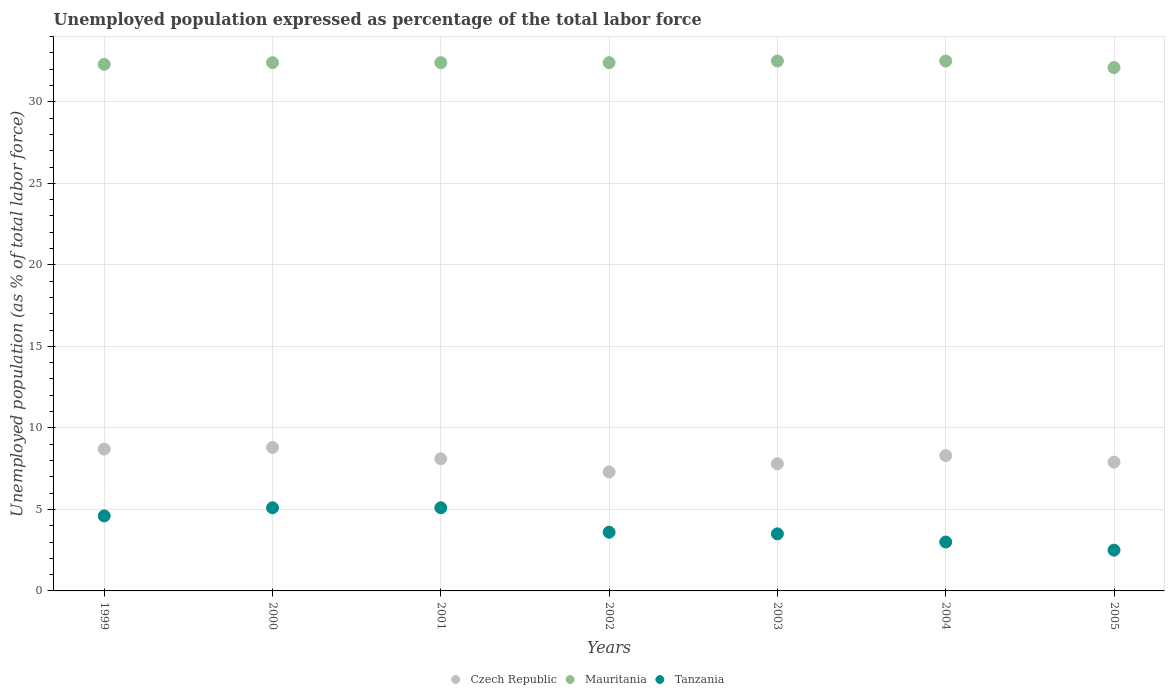How many different coloured dotlines are there?
Offer a very short reply. 3. Is the number of dotlines equal to the number of legend labels?
Offer a very short reply. Yes. What is the unemployment in in Mauritania in 2005?
Ensure brevity in your answer.  32.1. Across all years, what is the maximum unemployment in in Czech Republic?
Your answer should be very brief. 8.8. Across all years, what is the minimum unemployment in in Mauritania?
Provide a short and direct response. 32.1. In which year was the unemployment in in Czech Republic maximum?
Your answer should be very brief. 2000. In which year was the unemployment in in Mauritania minimum?
Offer a very short reply. 2005. What is the total unemployment in in Mauritania in the graph?
Offer a very short reply. 226.6. What is the difference between the unemployment in in Mauritania in 2003 and that in 2005?
Offer a very short reply. 0.4. What is the difference between the unemployment in in Czech Republic in 2000 and the unemployment in in Mauritania in 2005?
Offer a terse response. -23.3. What is the average unemployment in in Czech Republic per year?
Your response must be concise. 8.13. In the year 2000, what is the difference between the unemployment in in Tanzania and unemployment in in Mauritania?
Provide a short and direct response. -27.3. What is the ratio of the unemployment in in Tanzania in 2002 to that in 2003?
Your response must be concise. 1.03. Is the unemployment in in Mauritania in 1999 less than that in 2002?
Ensure brevity in your answer.  Yes. Is the difference between the unemployment in in Tanzania in 1999 and 2004 greater than the difference between the unemployment in in Mauritania in 1999 and 2004?
Your answer should be very brief. Yes. What is the difference between the highest and the second highest unemployment in in Czech Republic?
Your answer should be compact. 0.1. What is the difference between the highest and the lowest unemployment in in Mauritania?
Keep it short and to the point. 0.4. In how many years, is the unemployment in in Tanzania greater than the average unemployment in in Tanzania taken over all years?
Make the answer very short. 3. Is it the case that in every year, the sum of the unemployment in in Mauritania and unemployment in in Tanzania  is greater than the unemployment in in Czech Republic?
Your answer should be very brief. Yes. Does the unemployment in in Czech Republic monotonically increase over the years?
Your answer should be compact. No. Is the unemployment in in Tanzania strictly greater than the unemployment in in Mauritania over the years?
Offer a terse response. No. What is the difference between two consecutive major ticks on the Y-axis?
Offer a terse response. 5. Are the values on the major ticks of Y-axis written in scientific E-notation?
Make the answer very short. No. Does the graph contain any zero values?
Offer a terse response. No. Does the graph contain grids?
Your answer should be compact. Yes. What is the title of the graph?
Ensure brevity in your answer.  Unemployed population expressed as percentage of the total labor force. What is the label or title of the X-axis?
Offer a very short reply. Years. What is the label or title of the Y-axis?
Keep it short and to the point. Unemployed population (as % of total labor force). What is the Unemployed population (as % of total labor force) in Czech Republic in 1999?
Ensure brevity in your answer.  8.7. What is the Unemployed population (as % of total labor force) of Mauritania in 1999?
Provide a succinct answer. 32.3. What is the Unemployed population (as % of total labor force) of Tanzania in 1999?
Offer a terse response. 4.6. What is the Unemployed population (as % of total labor force) in Czech Republic in 2000?
Offer a very short reply. 8.8. What is the Unemployed population (as % of total labor force) of Mauritania in 2000?
Provide a succinct answer. 32.4. What is the Unemployed population (as % of total labor force) of Tanzania in 2000?
Keep it short and to the point. 5.1. What is the Unemployed population (as % of total labor force) of Czech Republic in 2001?
Your answer should be compact. 8.1. What is the Unemployed population (as % of total labor force) of Mauritania in 2001?
Ensure brevity in your answer.  32.4. What is the Unemployed population (as % of total labor force) of Tanzania in 2001?
Your answer should be compact. 5.1. What is the Unemployed population (as % of total labor force) of Czech Republic in 2002?
Your response must be concise. 7.3. What is the Unemployed population (as % of total labor force) of Mauritania in 2002?
Provide a short and direct response. 32.4. What is the Unemployed population (as % of total labor force) in Tanzania in 2002?
Your answer should be compact. 3.6. What is the Unemployed population (as % of total labor force) of Czech Republic in 2003?
Provide a short and direct response. 7.8. What is the Unemployed population (as % of total labor force) of Mauritania in 2003?
Your answer should be compact. 32.5. What is the Unemployed population (as % of total labor force) of Czech Republic in 2004?
Offer a terse response. 8.3. What is the Unemployed population (as % of total labor force) in Mauritania in 2004?
Ensure brevity in your answer.  32.5. What is the Unemployed population (as % of total labor force) of Czech Republic in 2005?
Offer a terse response. 7.9. What is the Unemployed population (as % of total labor force) of Mauritania in 2005?
Keep it short and to the point. 32.1. What is the Unemployed population (as % of total labor force) in Tanzania in 2005?
Make the answer very short. 2.5. Across all years, what is the maximum Unemployed population (as % of total labor force) in Czech Republic?
Provide a succinct answer. 8.8. Across all years, what is the maximum Unemployed population (as % of total labor force) of Mauritania?
Give a very brief answer. 32.5. Across all years, what is the maximum Unemployed population (as % of total labor force) in Tanzania?
Your answer should be very brief. 5.1. Across all years, what is the minimum Unemployed population (as % of total labor force) of Czech Republic?
Provide a succinct answer. 7.3. Across all years, what is the minimum Unemployed population (as % of total labor force) of Mauritania?
Offer a terse response. 32.1. What is the total Unemployed population (as % of total labor force) of Czech Republic in the graph?
Your response must be concise. 56.9. What is the total Unemployed population (as % of total labor force) of Mauritania in the graph?
Offer a very short reply. 226.6. What is the total Unemployed population (as % of total labor force) of Tanzania in the graph?
Ensure brevity in your answer.  27.4. What is the difference between the Unemployed population (as % of total labor force) in Czech Republic in 1999 and that in 2000?
Offer a very short reply. -0.1. What is the difference between the Unemployed population (as % of total labor force) in Mauritania in 1999 and that in 2000?
Your response must be concise. -0.1. What is the difference between the Unemployed population (as % of total labor force) of Czech Republic in 1999 and that in 2002?
Offer a terse response. 1.4. What is the difference between the Unemployed population (as % of total labor force) in Mauritania in 1999 and that in 2002?
Your response must be concise. -0.1. What is the difference between the Unemployed population (as % of total labor force) in Tanzania in 1999 and that in 2002?
Your answer should be very brief. 1. What is the difference between the Unemployed population (as % of total labor force) in Czech Republic in 1999 and that in 2003?
Provide a short and direct response. 0.9. What is the difference between the Unemployed population (as % of total labor force) in Mauritania in 1999 and that in 2003?
Provide a succinct answer. -0.2. What is the difference between the Unemployed population (as % of total labor force) of Tanzania in 1999 and that in 2003?
Keep it short and to the point. 1.1. What is the difference between the Unemployed population (as % of total labor force) in Czech Republic in 1999 and that in 2004?
Provide a short and direct response. 0.4. What is the difference between the Unemployed population (as % of total labor force) in Mauritania in 1999 and that in 2004?
Offer a very short reply. -0.2. What is the difference between the Unemployed population (as % of total labor force) in Tanzania in 1999 and that in 2004?
Make the answer very short. 1.6. What is the difference between the Unemployed population (as % of total labor force) in Mauritania in 1999 and that in 2005?
Give a very brief answer. 0.2. What is the difference between the Unemployed population (as % of total labor force) in Tanzania in 1999 and that in 2005?
Make the answer very short. 2.1. What is the difference between the Unemployed population (as % of total labor force) of Mauritania in 2000 and that in 2001?
Make the answer very short. 0. What is the difference between the Unemployed population (as % of total labor force) of Tanzania in 2000 and that in 2001?
Your answer should be very brief. 0. What is the difference between the Unemployed population (as % of total labor force) in Mauritania in 2000 and that in 2002?
Your answer should be compact. 0. What is the difference between the Unemployed population (as % of total labor force) of Tanzania in 2000 and that in 2002?
Make the answer very short. 1.5. What is the difference between the Unemployed population (as % of total labor force) in Czech Republic in 2000 and that in 2003?
Your answer should be very brief. 1. What is the difference between the Unemployed population (as % of total labor force) of Tanzania in 2000 and that in 2003?
Provide a succinct answer. 1.6. What is the difference between the Unemployed population (as % of total labor force) in Czech Republic in 2000 and that in 2004?
Offer a very short reply. 0.5. What is the difference between the Unemployed population (as % of total labor force) of Tanzania in 2000 and that in 2004?
Give a very brief answer. 2.1. What is the difference between the Unemployed population (as % of total labor force) of Tanzania in 2000 and that in 2005?
Your answer should be very brief. 2.6. What is the difference between the Unemployed population (as % of total labor force) of Czech Republic in 2001 and that in 2002?
Ensure brevity in your answer.  0.8. What is the difference between the Unemployed population (as % of total labor force) in Tanzania in 2001 and that in 2002?
Ensure brevity in your answer.  1.5. What is the difference between the Unemployed population (as % of total labor force) of Mauritania in 2001 and that in 2003?
Your response must be concise. -0.1. What is the difference between the Unemployed population (as % of total labor force) in Mauritania in 2001 and that in 2004?
Provide a succinct answer. -0.1. What is the difference between the Unemployed population (as % of total labor force) of Mauritania in 2001 and that in 2005?
Make the answer very short. 0.3. What is the difference between the Unemployed population (as % of total labor force) of Czech Republic in 2002 and that in 2005?
Offer a very short reply. -0.6. What is the difference between the Unemployed population (as % of total labor force) of Tanzania in 2002 and that in 2005?
Provide a succinct answer. 1.1. What is the difference between the Unemployed population (as % of total labor force) in Czech Republic in 2003 and that in 2004?
Offer a terse response. -0.5. What is the difference between the Unemployed population (as % of total labor force) of Mauritania in 2003 and that in 2004?
Your answer should be compact. 0. What is the difference between the Unemployed population (as % of total labor force) of Czech Republic in 2003 and that in 2005?
Make the answer very short. -0.1. What is the difference between the Unemployed population (as % of total labor force) in Tanzania in 2004 and that in 2005?
Offer a very short reply. 0.5. What is the difference between the Unemployed population (as % of total labor force) in Czech Republic in 1999 and the Unemployed population (as % of total labor force) in Mauritania in 2000?
Provide a short and direct response. -23.7. What is the difference between the Unemployed population (as % of total labor force) in Czech Republic in 1999 and the Unemployed population (as % of total labor force) in Tanzania in 2000?
Your answer should be compact. 3.6. What is the difference between the Unemployed population (as % of total labor force) in Mauritania in 1999 and the Unemployed population (as % of total labor force) in Tanzania in 2000?
Your response must be concise. 27.2. What is the difference between the Unemployed population (as % of total labor force) of Czech Republic in 1999 and the Unemployed population (as % of total labor force) of Mauritania in 2001?
Provide a short and direct response. -23.7. What is the difference between the Unemployed population (as % of total labor force) in Mauritania in 1999 and the Unemployed population (as % of total labor force) in Tanzania in 2001?
Offer a very short reply. 27.2. What is the difference between the Unemployed population (as % of total labor force) in Czech Republic in 1999 and the Unemployed population (as % of total labor force) in Mauritania in 2002?
Your response must be concise. -23.7. What is the difference between the Unemployed population (as % of total labor force) in Czech Republic in 1999 and the Unemployed population (as % of total labor force) in Tanzania in 2002?
Ensure brevity in your answer.  5.1. What is the difference between the Unemployed population (as % of total labor force) in Mauritania in 1999 and the Unemployed population (as % of total labor force) in Tanzania in 2002?
Make the answer very short. 28.7. What is the difference between the Unemployed population (as % of total labor force) in Czech Republic in 1999 and the Unemployed population (as % of total labor force) in Mauritania in 2003?
Keep it short and to the point. -23.8. What is the difference between the Unemployed population (as % of total labor force) in Mauritania in 1999 and the Unemployed population (as % of total labor force) in Tanzania in 2003?
Make the answer very short. 28.8. What is the difference between the Unemployed population (as % of total labor force) of Czech Republic in 1999 and the Unemployed population (as % of total labor force) of Mauritania in 2004?
Ensure brevity in your answer.  -23.8. What is the difference between the Unemployed population (as % of total labor force) of Czech Republic in 1999 and the Unemployed population (as % of total labor force) of Tanzania in 2004?
Provide a short and direct response. 5.7. What is the difference between the Unemployed population (as % of total labor force) in Mauritania in 1999 and the Unemployed population (as % of total labor force) in Tanzania in 2004?
Your response must be concise. 29.3. What is the difference between the Unemployed population (as % of total labor force) of Czech Republic in 1999 and the Unemployed population (as % of total labor force) of Mauritania in 2005?
Ensure brevity in your answer.  -23.4. What is the difference between the Unemployed population (as % of total labor force) of Czech Republic in 1999 and the Unemployed population (as % of total labor force) of Tanzania in 2005?
Ensure brevity in your answer.  6.2. What is the difference between the Unemployed population (as % of total labor force) in Mauritania in 1999 and the Unemployed population (as % of total labor force) in Tanzania in 2005?
Provide a succinct answer. 29.8. What is the difference between the Unemployed population (as % of total labor force) in Czech Republic in 2000 and the Unemployed population (as % of total labor force) in Mauritania in 2001?
Provide a succinct answer. -23.6. What is the difference between the Unemployed population (as % of total labor force) in Mauritania in 2000 and the Unemployed population (as % of total labor force) in Tanzania in 2001?
Your response must be concise. 27.3. What is the difference between the Unemployed population (as % of total labor force) in Czech Republic in 2000 and the Unemployed population (as % of total labor force) in Mauritania in 2002?
Provide a short and direct response. -23.6. What is the difference between the Unemployed population (as % of total labor force) in Mauritania in 2000 and the Unemployed population (as % of total labor force) in Tanzania in 2002?
Your answer should be compact. 28.8. What is the difference between the Unemployed population (as % of total labor force) in Czech Republic in 2000 and the Unemployed population (as % of total labor force) in Mauritania in 2003?
Your answer should be compact. -23.7. What is the difference between the Unemployed population (as % of total labor force) of Mauritania in 2000 and the Unemployed population (as % of total labor force) of Tanzania in 2003?
Give a very brief answer. 28.9. What is the difference between the Unemployed population (as % of total labor force) in Czech Republic in 2000 and the Unemployed population (as % of total labor force) in Mauritania in 2004?
Your response must be concise. -23.7. What is the difference between the Unemployed population (as % of total labor force) in Czech Republic in 2000 and the Unemployed population (as % of total labor force) in Tanzania in 2004?
Your answer should be very brief. 5.8. What is the difference between the Unemployed population (as % of total labor force) of Mauritania in 2000 and the Unemployed population (as % of total labor force) of Tanzania in 2004?
Your answer should be very brief. 29.4. What is the difference between the Unemployed population (as % of total labor force) in Czech Republic in 2000 and the Unemployed population (as % of total labor force) in Mauritania in 2005?
Make the answer very short. -23.3. What is the difference between the Unemployed population (as % of total labor force) in Mauritania in 2000 and the Unemployed population (as % of total labor force) in Tanzania in 2005?
Make the answer very short. 29.9. What is the difference between the Unemployed population (as % of total labor force) of Czech Republic in 2001 and the Unemployed population (as % of total labor force) of Mauritania in 2002?
Provide a succinct answer. -24.3. What is the difference between the Unemployed population (as % of total labor force) of Mauritania in 2001 and the Unemployed population (as % of total labor force) of Tanzania in 2002?
Your answer should be compact. 28.8. What is the difference between the Unemployed population (as % of total labor force) in Czech Republic in 2001 and the Unemployed population (as % of total labor force) in Mauritania in 2003?
Your answer should be very brief. -24.4. What is the difference between the Unemployed population (as % of total labor force) in Czech Republic in 2001 and the Unemployed population (as % of total labor force) in Tanzania in 2003?
Keep it short and to the point. 4.6. What is the difference between the Unemployed population (as % of total labor force) of Mauritania in 2001 and the Unemployed population (as % of total labor force) of Tanzania in 2003?
Give a very brief answer. 28.9. What is the difference between the Unemployed population (as % of total labor force) in Czech Republic in 2001 and the Unemployed population (as % of total labor force) in Mauritania in 2004?
Keep it short and to the point. -24.4. What is the difference between the Unemployed population (as % of total labor force) of Mauritania in 2001 and the Unemployed population (as % of total labor force) of Tanzania in 2004?
Provide a succinct answer. 29.4. What is the difference between the Unemployed population (as % of total labor force) in Mauritania in 2001 and the Unemployed population (as % of total labor force) in Tanzania in 2005?
Your answer should be compact. 29.9. What is the difference between the Unemployed population (as % of total labor force) in Czech Republic in 2002 and the Unemployed population (as % of total labor force) in Mauritania in 2003?
Offer a very short reply. -25.2. What is the difference between the Unemployed population (as % of total labor force) of Mauritania in 2002 and the Unemployed population (as % of total labor force) of Tanzania in 2003?
Your answer should be compact. 28.9. What is the difference between the Unemployed population (as % of total labor force) of Czech Republic in 2002 and the Unemployed population (as % of total labor force) of Mauritania in 2004?
Provide a succinct answer. -25.2. What is the difference between the Unemployed population (as % of total labor force) in Czech Republic in 2002 and the Unemployed population (as % of total labor force) in Tanzania in 2004?
Offer a very short reply. 4.3. What is the difference between the Unemployed population (as % of total labor force) of Mauritania in 2002 and the Unemployed population (as % of total labor force) of Tanzania in 2004?
Keep it short and to the point. 29.4. What is the difference between the Unemployed population (as % of total labor force) in Czech Republic in 2002 and the Unemployed population (as % of total labor force) in Mauritania in 2005?
Make the answer very short. -24.8. What is the difference between the Unemployed population (as % of total labor force) of Mauritania in 2002 and the Unemployed population (as % of total labor force) of Tanzania in 2005?
Provide a succinct answer. 29.9. What is the difference between the Unemployed population (as % of total labor force) in Czech Republic in 2003 and the Unemployed population (as % of total labor force) in Mauritania in 2004?
Keep it short and to the point. -24.7. What is the difference between the Unemployed population (as % of total labor force) of Mauritania in 2003 and the Unemployed population (as % of total labor force) of Tanzania in 2004?
Keep it short and to the point. 29.5. What is the difference between the Unemployed population (as % of total labor force) in Czech Republic in 2003 and the Unemployed population (as % of total labor force) in Mauritania in 2005?
Provide a succinct answer. -24.3. What is the difference between the Unemployed population (as % of total labor force) of Czech Republic in 2004 and the Unemployed population (as % of total labor force) of Mauritania in 2005?
Ensure brevity in your answer.  -23.8. What is the average Unemployed population (as % of total labor force) in Czech Republic per year?
Offer a terse response. 8.13. What is the average Unemployed population (as % of total labor force) of Mauritania per year?
Provide a short and direct response. 32.37. What is the average Unemployed population (as % of total labor force) in Tanzania per year?
Give a very brief answer. 3.91. In the year 1999, what is the difference between the Unemployed population (as % of total labor force) of Czech Republic and Unemployed population (as % of total labor force) of Mauritania?
Your answer should be compact. -23.6. In the year 1999, what is the difference between the Unemployed population (as % of total labor force) of Czech Republic and Unemployed population (as % of total labor force) of Tanzania?
Provide a succinct answer. 4.1. In the year 1999, what is the difference between the Unemployed population (as % of total labor force) of Mauritania and Unemployed population (as % of total labor force) of Tanzania?
Keep it short and to the point. 27.7. In the year 2000, what is the difference between the Unemployed population (as % of total labor force) in Czech Republic and Unemployed population (as % of total labor force) in Mauritania?
Offer a very short reply. -23.6. In the year 2000, what is the difference between the Unemployed population (as % of total labor force) of Mauritania and Unemployed population (as % of total labor force) of Tanzania?
Offer a very short reply. 27.3. In the year 2001, what is the difference between the Unemployed population (as % of total labor force) of Czech Republic and Unemployed population (as % of total labor force) of Mauritania?
Provide a succinct answer. -24.3. In the year 2001, what is the difference between the Unemployed population (as % of total labor force) in Czech Republic and Unemployed population (as % of total labor force) in Tanzania?
Provide a short and direct response. 3. In the year 2001, what is the difference between the Unemployed population (as % of total labor force) of Mauritania and Unemployed population (as % of total labor force) of Tanzania?
Provide a succinct answer. 27.3. In the year 2002, what is the difference between the Unemployed population (as % of total labor force) in Czech Republic and Unemployed population (as % of total labor force) in Mauritania?
Your response must be concise. -25.1. In the year 2002, what is the difference between the Unemployed population (as % of total labor force) in Mauritania and Unemployed population (as % of total labor force) in Tanzania?
Keep it short and to the point. 28.8. In the year 2003, what is the difference between the Unemployed population (as % of total labor force) in Czech Republic and Unemployed population (as % of total labor force) in Mauritania?
Keep it short and to the point. -24.7. In the year 2004, what is the difference between the Unemployed population (as % of total labor force) of Czech Republic and Unemployed population (as % of total labor force) of Mauritania?
Give a very brief answer. -24.2. In the year 2004, what is the difference between the Unemployed population (as % of total labor force) in Mauritania and Unemployed population (as % of total labor force) in Tanzania?
Your answer should be compact. 29.5. In the year 2005, what is the difference between the Unemployed population (as % of total labor force) in Czech Republic and Unemployed population (as % of total labor force) in Mauritania?
Provide a short and direct response. -24.2. In the year 2005, what is the difference between the Unemployed population (as % of total labor force) of Czech Republic and Unemployed population (as % of total labor force) of Tanzania?
Make the answer very short. 5.4. In the year 2005, what is the difference between the Unemployed population (as % of total labor force) in Mauritania and Unemployed population (as % of total labor force) in Tanzania?
Provide a short and direct response. 29.6. What is the ratio of the Unemployed population (as % of total labor force) of Czech Republic in 1999 to that in 2000?
Your answer should be compact. 0.99. What is the ratio of the Unemployed population (as % of total labor force) of Mauritania in 1999 to that in 2000?
Your answer should be compact. 1. What is the ratio of the Unemployed population (as % of total labor force) in Tanzania in 1999 to that in 2000?
Your response must be concise. 0.9. What is the ratio of the Unemployed population (as % of total labor force) in Czech Republic in 1999 to that in 2001?
Your answer should be compact. 1.07. What is the ratio of the Unemployed population (as % of total labor force) in Mauritania in 1999 to that in 2001?
Your answer should be compact. 1. What is the ratio of the Unemployed population (as % of total labor force) in Tanzania in 1999 to that in 2001?
Provide a short and direct response. 0.9. What is the ratio of the Unemployed population (as % of total labor force) of Czech Republic in 1999 to that in 2002?
Ensure brevity in your answer.  1.19. What is the ratio of the Unemployed population (as % of total labor force) of Mauritania in 1999 to that in 2002?
Offer a very short reply. 1. What is the ratio of the Unemployed population (as % of total labor force) of Tanzania in 1999 to that in 2002?
Ensure brevity in your answer.  1.28. What is the ratio of the Unemployed population (as % of total labor force) of Czech Republic in 1999 to that in 2003?
Provide a short and direct response. 1.12. What is the ratio of the Unemployed population (as % of total labor force) in Mauritania in 1999 to that in 2003?
Keep it short and to the point. 0.99. What is the ratio of the Unemployed population (as % of total labor force) in Tanzania in 1999 to that in 2003?
Offer a very short reply. 1.31. What is the ratio of the Unemployed population (as % of total labor force) in Czech Republic in 1999 to that in 2004?
Provide a succinct answer. 1.05. What is the ratio of the Unemployed population (as % of total labor force) of Mauritania in 1999 to that in 2004?
Your response must be concise. 0.99. What is the ratio of the Unemployed population (as % of total labor force) in Tanzania in 1999 to that in 2004?
Your answer should be compact. 1.53. What is the ratio of the Unemployed population (as % of total labor force) of Czech Republic in 1999 to that in 2005?
Your answer should be very brief. 1.1. What is the ratio of the Unemployed population (as % of total labor force) of Tanzania in 1999 to that in 2005?
Offer a terse response. 1.84. What is the ratio of the Unemployed population (as % of total labor force) in Czech Republic in 2000 to that in 2001?
Your answer should be very brief. 1.09. What is the ratio of the Unemployed population (as % of total labor force) of Mauritania in 2000 to that in 2001?
Your response must be concise. 1. What is the ratio of the Unemployed population (as % of total labor force) in Tanzania in 2000 to that in 2001?
Make the answer very short. 1. What is the ratio of the Unemployed population (as % of total labor force) of Czech Republic in 2000 to that in 2002?
Keep it short and to the point. 1.21. What is the ratio of the Unemployed population (as % of total labor force) in Tanzania in 2000 to that in 2002?
Provide a short and direct response. 1.42. What is the ratio of the Unemployed population (as % of total labor force) in Czech Republic in 2000 to that in 2003?
Offer a terse response. 1.13. What is the ratio of the Unemployed population (as % of total labor force) in Mauritania in 2000 to that in 2003?
Offer a very short reply. 1. What is the ratio of the Unemployed population (as % of total labor force) of Tanzania in 2000 to that in 2003?
Your answer should be very brief. 1.46. What is the ratio of the Unemployed population (as % of total labor force) of Czech Republic in 2000 to that in 2004?
Offer a very short reply. 1.06. What is the ratio of the Unemployed population (as % of total labor force) of Tanzania in 2000 to that in 2004?
Provide a succinct answer. 1.7. What is the ratio of the Unemployed population (as % of total labor force) of Czech Republic in 2000 to that in 2005?
Make the answer very short. 1.11. What is the ratio of the Unemployed population (as % of total labor force) in Mauritania in 2000 to that in 2005?
Your response must be concise. 1.01. What is the ratio of the Unemployed population (as % of total labor force) of Tanzania in 2000 to that in 2005?
Your response must be concise. 2.04. What is the ratio of the Unemployed population (as % of total labor force) in Czech Republic in 2001 to that in 2002?
Your answer should be compact. 1.11. What is the ratio of the Unemployed population (as % of total labor force) of Mauritania in 2001 to that in 2002?
Your answer should be very brief. 1. What is the ratio of the Unemployed population (as % of total labor force) in Tanzania in 2001 to that in 2002?
Keep it short and to the point. 1.42. What is the ratio of the Unemployed population (as % of total labor force) of Czech Republic in 2001 to that in 2003?
Keep it short and to the point. 1.04. What is the ratio of the Unemployed population (as % of total labor force) in Tanzania in 2001 to that in 2003?
Provide a succinct answer. 1.46. What is the ratio of the Unemployed population (as % of total labor force) in Czech Republic in 2001 to that in 2004?
Provide a succinct answer. 0.98. What is the ratio of the Unemployed population (as % of total labor force) of Mauritania in 2001 to that in 2004?
Provide a short and direct response. 1. What is the ratio of the Unemployed population (as % of total labor force) of Tanzania in 2001 to that in 2004?
Give a very brief answer. 1.7. What is the ratio of the Unemployed population (as % of total labor force) in Czech Republic in 2001 to that in 2005?
Provide a succinct answer. 1.03. What is the ratio of the Unemployed population (as % of total labor force) in Mauritania in 2001 to that in 2005?
Offer a terse response. 1.01. What is the ratio of the Unemployed population (as % of total labor force) in Tanzania in 2001 to that in 2005?
Offer a very short reply. 2.04. What is the ratio of the Unemployed population (as % of total labor force) in Czech Republic in 2002 to that in 2003?
Offer a terse response. 0.94. What is the ratio of the Unemployed population (as % of total labor force) in Mauritania in 2002 to that in 2003?
Ensure brevity in your answer.  1. What is the ratio of the Unemployed population (as % of total labor force) of Tanzania in 2002 to that in 2003?
Ensure brevity in your answer.  1.03. What is the ratio of the Unemployed population (as % of total labor force) in Czech Republic in 2002 to that in 2004?
Offer a very short reply. 0.88. What is the ratio of the Unemployed population (as % of total labor force) of Mauritania in 2002 to that in 2004?
Your answer should be compact. 1. What is the ratio of the Unemployed population (as % of total labor force) in Czech Republic in 2002 to that in 2005?
Keep it short and to the point. 0.92. What is the ratio of the Unemployed population (as % of total labor force) of Mauritania in 2002 to that in 2005?
Make the answer very short. 1.01. What is the ratio of the Unemployed population (as % of total labor force) of Tanzania in 2002 to that in 2005?
Your answer should be very brief. 1.44. What is the ratio of the Unemployed population (as % of total labor force) in Czech Republic in 2003 to that in 2004?
Your response must be concise. 0.94. What is the ratio of the Unemployed population (as % of total labor force) of Czech Republic in 2003 to that in 2005?
Give a very brief answer. 0.99. What is the ratio of the Unemployed population (as % of total labor force) in Mauritania in 2003 to that in 2005?
Your response must be concise. 1.01. What is the ratio of the Unemployed population (as % of total labor force) of Czech Republic in 2004 to that in 2005?
Your answer should be compact. 1.05. What is the ratio of the Unemployed population (as % of total labor force) in Mauritania in 2004 to that in 2005?
Provide a succinct answer. 1.01. What is the ratio of the Unemployed population (as % of total labor force) of Tanzania in 2004 to that in 2005?
Offer a very short reply. 1.2. What is the difference between the highest and the second highest Unemployed population (as % of total labor force) in Czech Republic?
Provide a short and direct response. 0.1. What is the difference between the highest and the second highest Unemployed population (as % of total labor force) of Tanzania?
Give a very brief answer. 0. What is the difference between the highest and the lowest Unemployed population (as % of total labor force) in Mauritania?
Your answer should be very brief. 0.4. What is the difference between the highest and the lowest Unemployed population (as % of total labor force) of Tanzania?
Your answer should be compact. 2.6. 